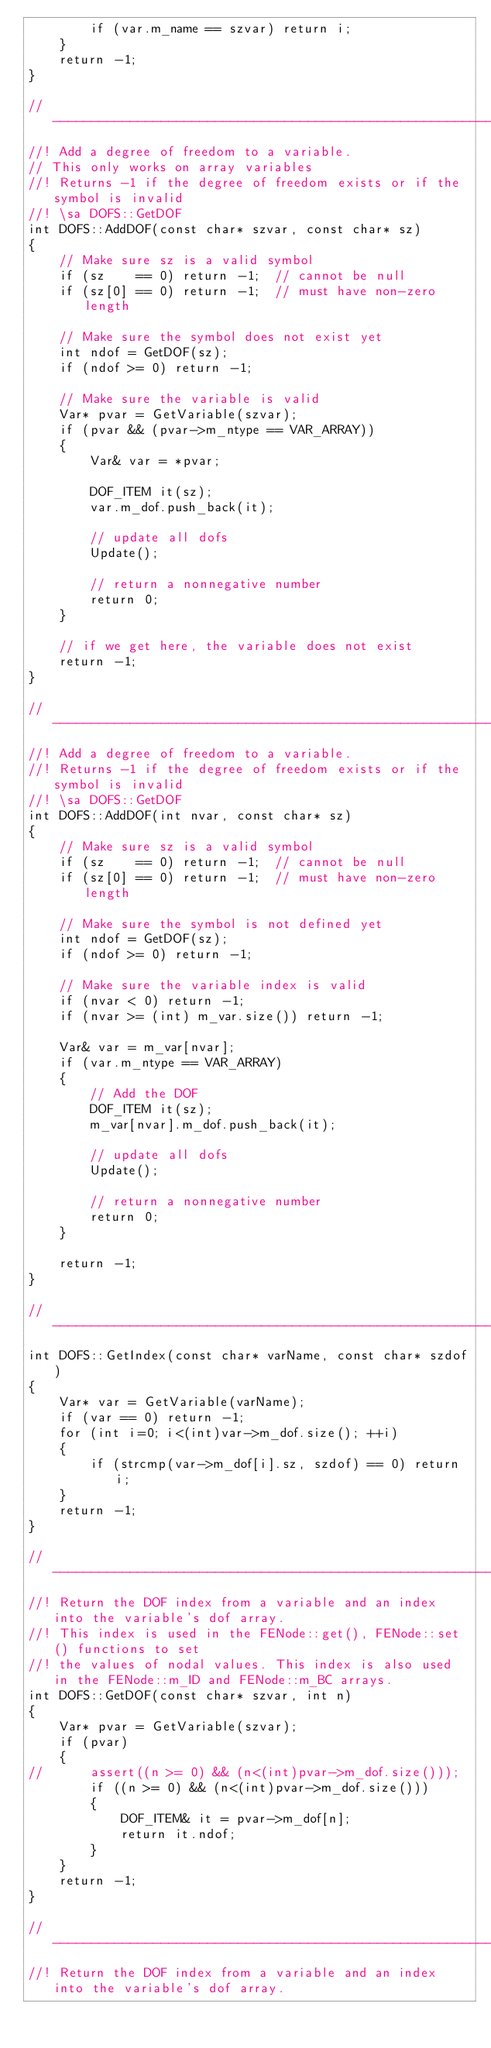<code> <loc_0><loc_0><loc_500><loc_500><_C++_>		if (var.m_name == szvar) return i;
	}
	return -1;
}

//-----------------------------------------------------------------------------
//! Add a degree of freedom to a variable.
// This only works on array variables
//! Returns -1 if the degree of freedom exists or if the symbol is invalid
//! \sa DOFS::GetDOF
int DOFS::AddDOF(const char* szvar, const char* sz)
{
	// Make sure sz is a valid symbol
	if (sz    == 0) return -1;	// cannot be null
	if (sz[0] == 0) return -1;	// must have non-zero length

	// Make sure the symbol does not exist yet
	int ndof = GetDOF(sz);
	if (ndof >= 0) return -1;

	// Make sure the variable is valid
	Var* pvar = GetVariable(szvar);
	if (pvar && (pvar->m_ntype == VAR_ARRAY))
	{
		Var& var = *pvar;

		DOF_ITEM it(sz);
		var.m_dof.push_back(it);

		// update all dofs
		Update();

		// return a nonnegative number
		return 0;
	}

	// if we get here, the variable does not exist
	return -1;
}

//-----------------------------------------------------------------------------
//! Add a degree of freedom to a variable.
//! Returns -1 if the degree of freedom exists or if the symbol is invalid
//! \sa DOFS::GetDOF
int DOFS::AddDOF(int nvar, const char* sz)
{
	// Make sure sz is a valid symbol
	if (sz    == 0) return -1;	// cannot be null
	if (sz[0] == 0) return -1;	// must have non-zero length

	// Make sure the symbol is not defined yet
	int ndof = GetDOF(sz);
	if (ndof >= 0) return -1;

	// Make sure the variable index is valid
	if (nvar < 0) return -1;
	if (nvar >= (int) m_var.size()) return -1; 

	Var& var = m_var[nvar];
	if (var.m_ntype == VAR_ARRAY)
	{
		// Add the DOF
		DOF_ITEM it(sz);
		m_var[nvar].m_dof.push_back(it);

		// update all dofs
		Update();

		// return a nonnegative number
		return 0;
	}

	return -1;
}

//-----------------------------------------------------------------------------
int DOFS::GetIndex(const char* varName, const char* szdof)
{
	Var* var = GetVariable(varName);
	if (var == 0) return -1;
	for (int i=0; i<(int)var->m_dof.size(); ++i)
	{
		if (strcmp(var->m_dof[i].sz, szdof) == 0) return i;
	}
	return -1;
}

//-----------------------------------------------------------------------------
//! Return the DOF index from a variable and an index into the variable's dof array.
//! This index is used in the FENode::get(), FENode::set() functions to set 
//! the values of nodal values. This index is also used in the FENode::m_ID and FENode::m_BC arrays.
int DOFS::GetDOF(const char* szvar, int n)
{
	Var* pvar = GetVariable(szvar);
	if (pvar)
	{
//		assert((n >= 0) && (n<(int)pvar->m_dof.size()));
		if ((n >= 0) && (n<(int)pvar->m_dof.size()))
		{
			DOF_ITEM& it = pvar->m_dof[n];
			return it.ndof;
		}
	}
	return -1;
}

//-----------------------------------------------------------------------------
//! Return the DOF index from a variable and an index into the variable's dof array.</code> 